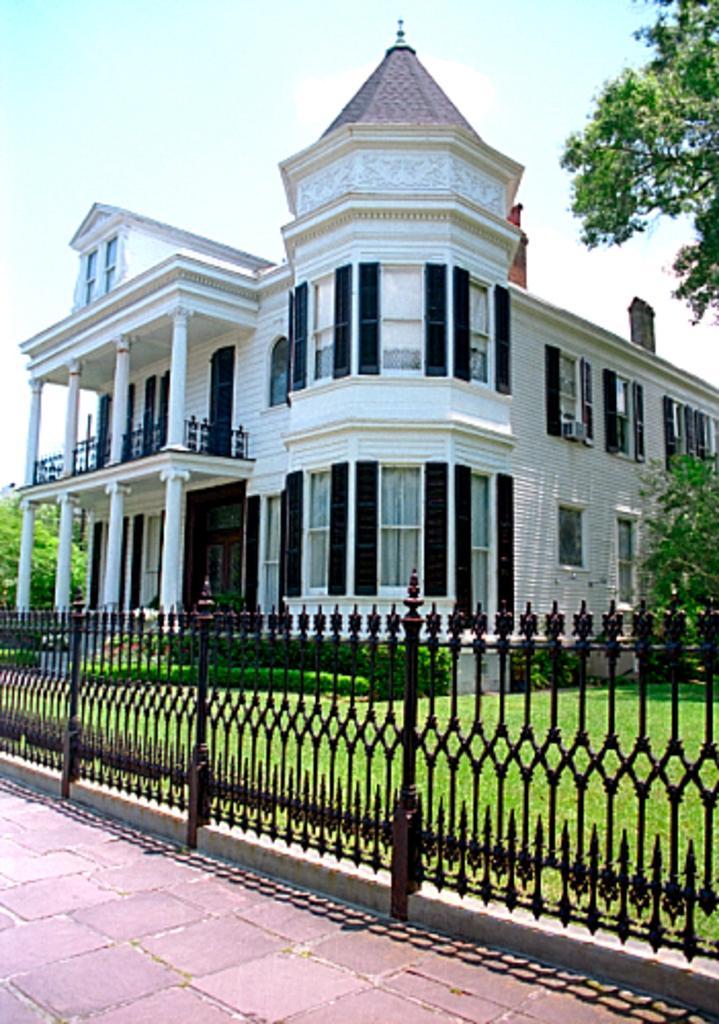How would you summarize this image in a sentence or two? In the picture we can see a house building with a pillar and windows to it and besides, we can see some plants, trees, and grass surface and railing beside it and we can also see a path with tiles. 